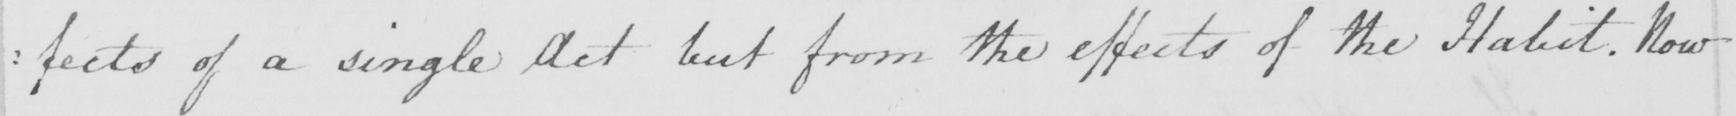What text is written in this handwritten line? :fects of a single Act but from the effects of the Habit. Now 